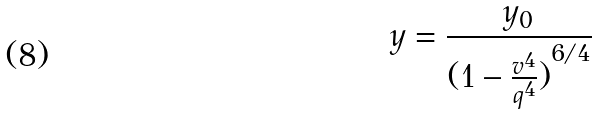<formula> <loc_0><loc_0><loc_500><loc_500>y = \frac { y _ { 0 } } { ( { 1 - \frac { v ^ { 4 } } { q ^ { 4 } } ) } ^ { 6 / 4 } }</formula> 